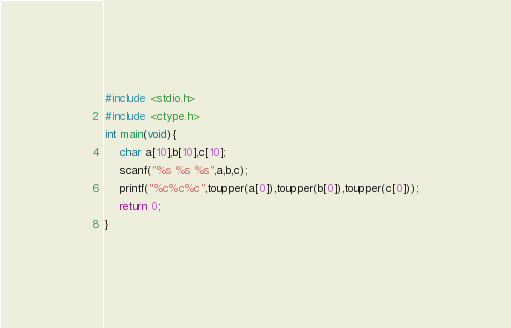Convert code to text. <code><loc_0><loc_0><loc_500><loc_500><_C_>#include <stdio.h>
#include <ctype.h>
int main(void){
    char a[10],b[10],c[10];
    scanf("%s %s %s",a,b,c);
    printf("%c%c%c",toupper(a[0]),toupper(b[0]),toupper(c[0]));
    return 0;
}</code> 